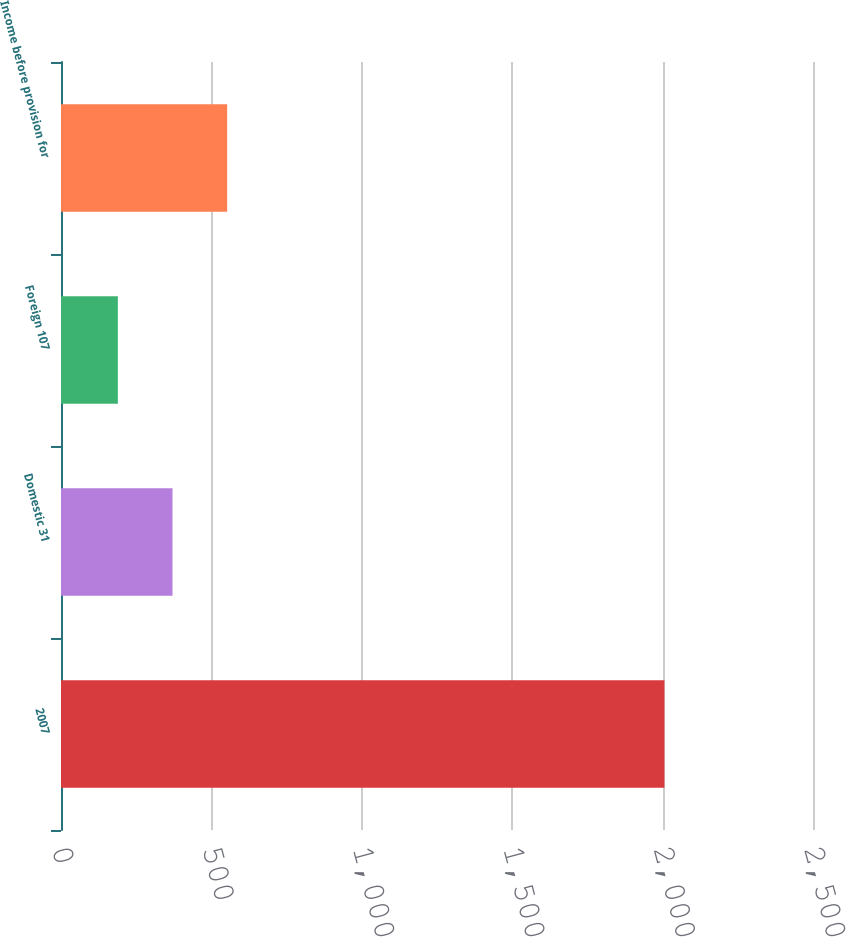Convert chart. <chart><loc_0><loc_0><loc_500><loc_500><bar_chart><fcel>2007<fcel>Domestic 31<fcel>Foreign 107<fcel>Income before provision for<nl><fcel>2006<fcel>370.7<fcel>189<fcel>552.4<nl></chart> 